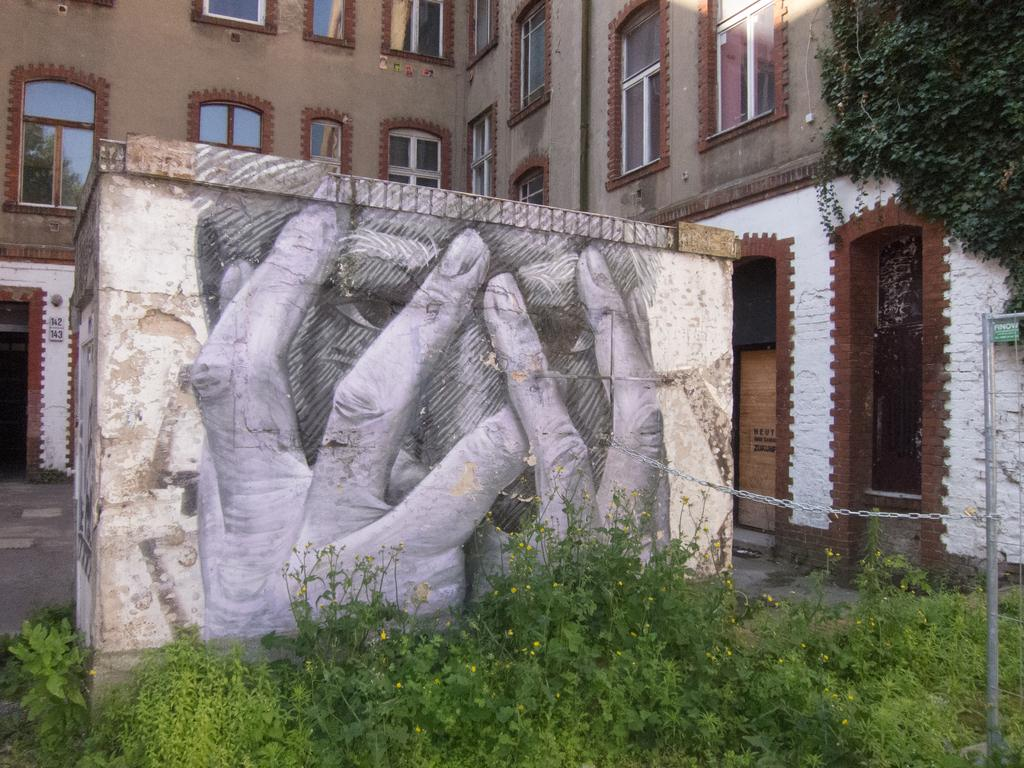What type of living organisms can be seen in the image? Plants can be seen in the image. What is the pole used for in the image? The purpose of the pole is not clear from the image. What is attached to the pole in the image? A chain is attached to the pole in the image. What is depicted on the wall in the image? There is a drawing on a wall in the image. What can be seen in the background of the image? There is a building, windows, and boards in the background of the image. What type of guide is present in the image to help the insects navigate the building? There is no guide or insects present in the image. What account number is associated with the boards in the background of the image? There is no account number associated with the boards in the image. 